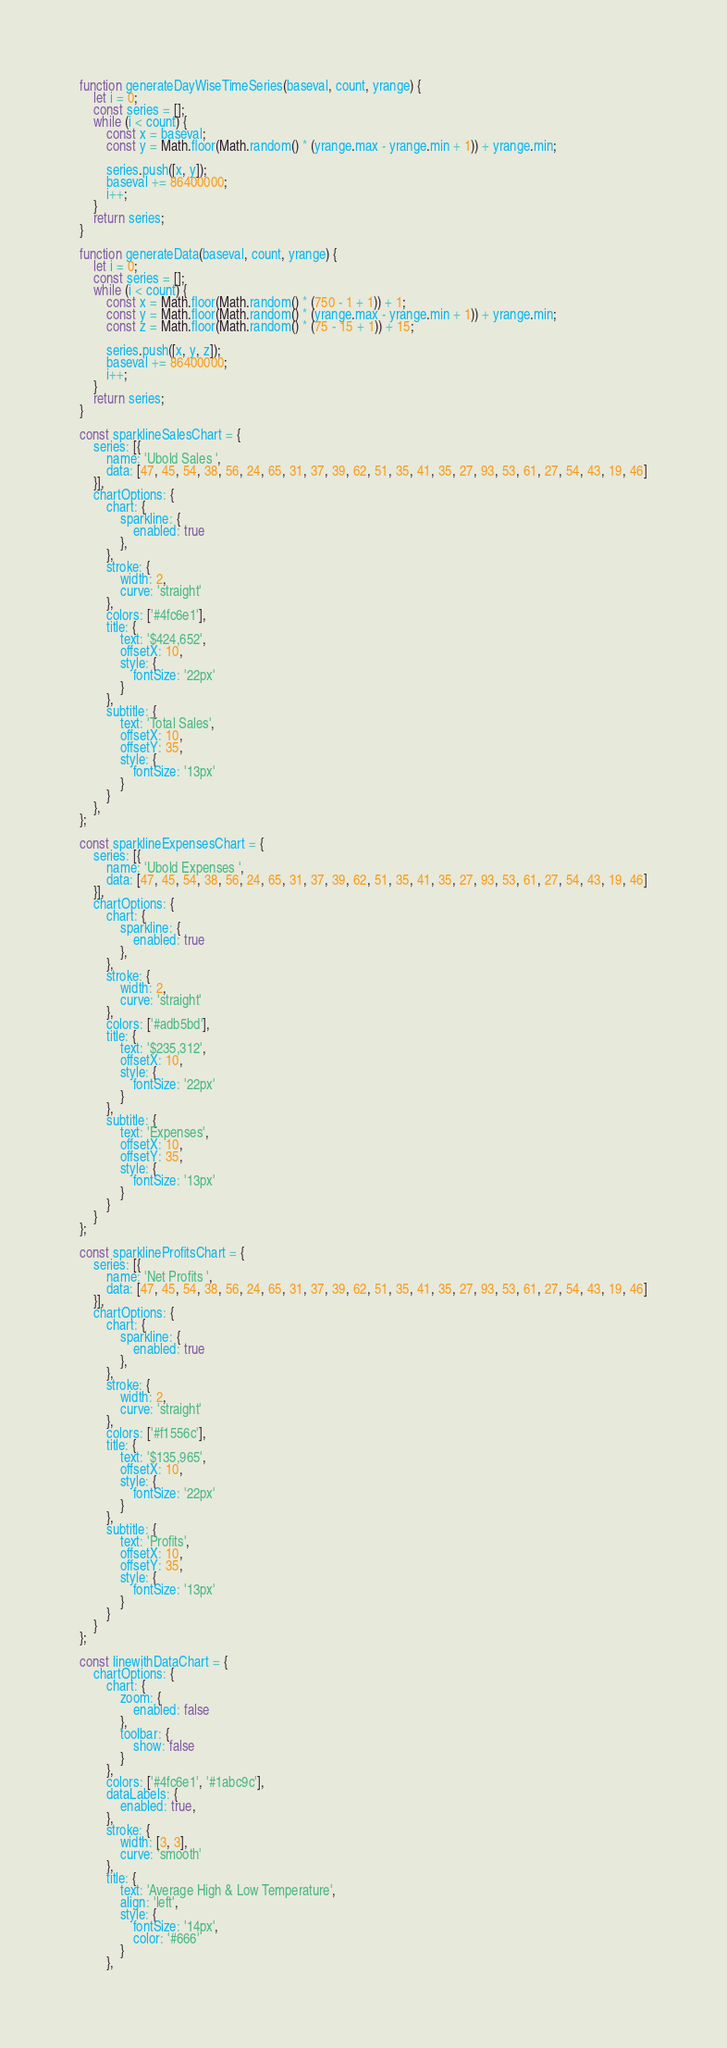Convert code to text. <code><loc_0><loc_0><loc_500><loc_500><_JavaScript_>function generateDayWiseTimeSeries(baseval, count, yrange) {
    let i = 0;
    const series = [];
    while (i < count) {
        const x = baseval;
        const y = Math.floor(Math.random() * (yrange.max - yrange.min + 1)) + yrange.min;

        series.push([x, y]);
        baseval += 86400000;
        i++;
    }
    return series;
}

function generateData(baseval, count, yrange) {
    let i = 0;
    const series = [];
    while (i < count) {
        const x = Math.floor(Math.random() * (750 - 1 + 1)) + 1;
        const y = Math.floor(Math.random() * (yrange.max - yrange.min + 1)) + yrange.min;
        const z = Math.floor(Math.random() * (75 - 15 + 1)) + 15;

        series.push([x, y, z]);
        baseval += 86400000;
        i++;
    }
    return series;
}

const sparklineSalesChart = {
    series: [{
        name: 'Ubold Sales ',
        data: [47, 45, 54, 38, 56, 24, 65, 31, 37, 39, 62, 51, 35, 41, 35, 27, 93, 53, 61, 27, 54, 43, 19, 46]
    }],
    chartOptions: {
        chart: {
            sparkline: {
                enabled: true
            },
        },
        stroke: {
            width: 2,
            curve: 'straight'
        },
        colors: ['#4fc6e1'],
        title: {
            text: '$424,652',
            offsetX: 10,
            style: {
                fontSize: '22px'
            }
        },
        subtitle: {
            text: 'Total Sales',
            offsetX: 10,
            offsetY: 35,
            style: {
                fontSize: '13px'
            }
        }
    },
};

const sparklineExpensesChart = {
    series: [{
        name: 'Ubold Expenses ',
        data: [47, 45, 54, 38, 56, 24, 65, 31, 37, 39, 62, 51, 35, 41, 35, 27, 93, 53, 61, 27, 54, 43, 19, 46]
    }],
    chartOptions: {
        chart: {
            sparkline: {
                enabled: true
            },
        },
        stroke: {
            width: 2,
            curve: 'straight'
        },
        colors: ['#adb5bd'],
        title: {
            text: '$235,312',
            offsetX: 10,
            style: {
                fontSize: '22px'
            }
        },
        subtitle: {
            text: 'Expenses',
            offsetX: 10,
            offsetY: 35,
            style: {
                fontSize: '13px'
            }
        }
    }
};

const sparklineProfitsChart = {
    series: [{
        name: 'Net Profits ',
        data: [47, 45, 54, 38, 56, 24, 65, 31, 37, 39, 62, 51, 35, 41, 35, 27, 93, 53, 61, 27, 54, 43, 19, 46]
    }],
    chartOptions: {
        chart: {
            sparkline: {
                enabled: true
            },
        },
        stroke: {
            width: 2,
            curve: 'straight'
        },
        colors: ['#f1556c'],
        title: {
            text: '$135,965',
            offsetX: 10,
            style: {
                fontSize: '22px'
            }
        },
        subtitle: {
            text: 'Profits',
            offsetX: 10,
            offsetY: 35,
            style: {
                fontSize: '13px'
            }
        }
    }
};

const linewithDataChart = {
    chartOptions: {
        chart: {
            zoom: {
                enabled: false
            },
            toolbar: {
                show: false
            }
        },
        colors: ['#4fc6e1', '#1abc9c'],
        dataLabels: {
            enabled: true,
        },
        stroke: {
            width: [3, 3],
            curve: 'smooth'
        },
        title: {
            text: 'Average High & Low Temperature',
            align: 'left',
            style: {
                fontSize: '14px',
                color: '#666'
            }
        },</code> 